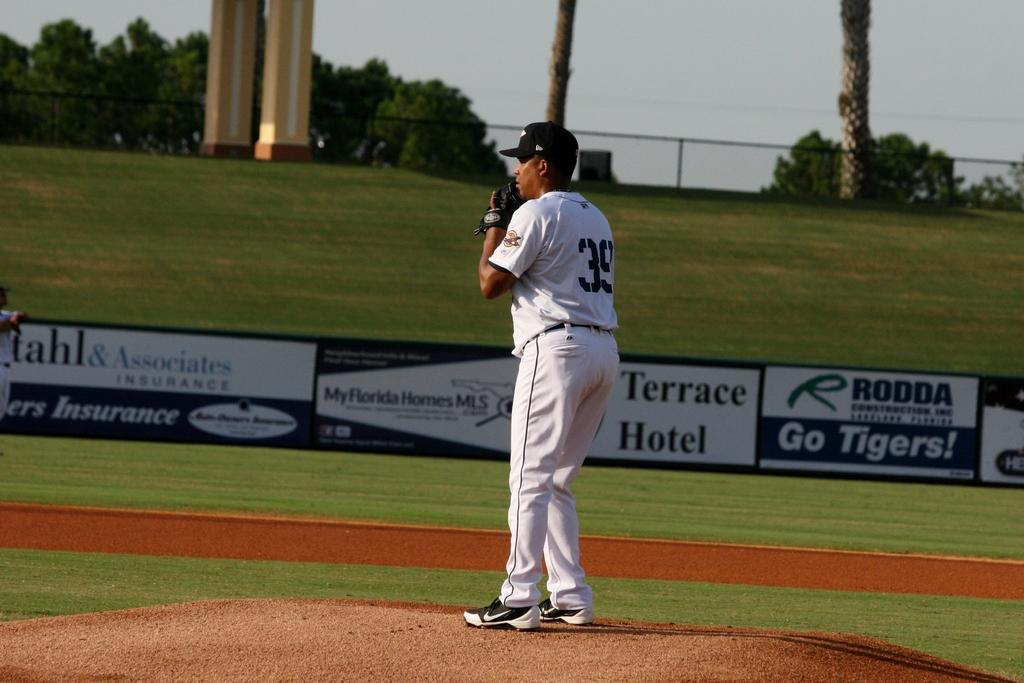<image>
Create a compact narrative representing the image presented. a pitcher with a large terrace hotel sign in the back 